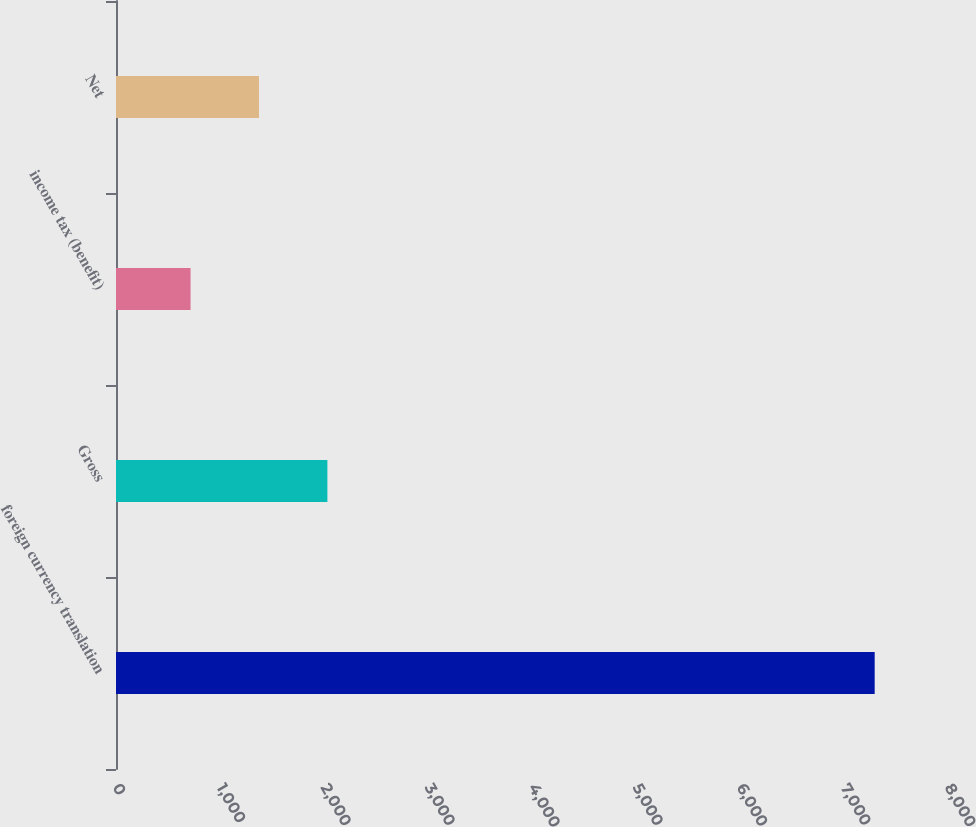Convert chart to OTSL. <chart><loc_0><loc_0><loc_500><loc_500><bar_chart><fcel>foreign currency translation<fcel>Gross<fcel>income tax (benefit)<fcel>Net<nl><fcel>7295<fcel>2032.6<fcel>717<fcel>1374.8<nl></chart> 